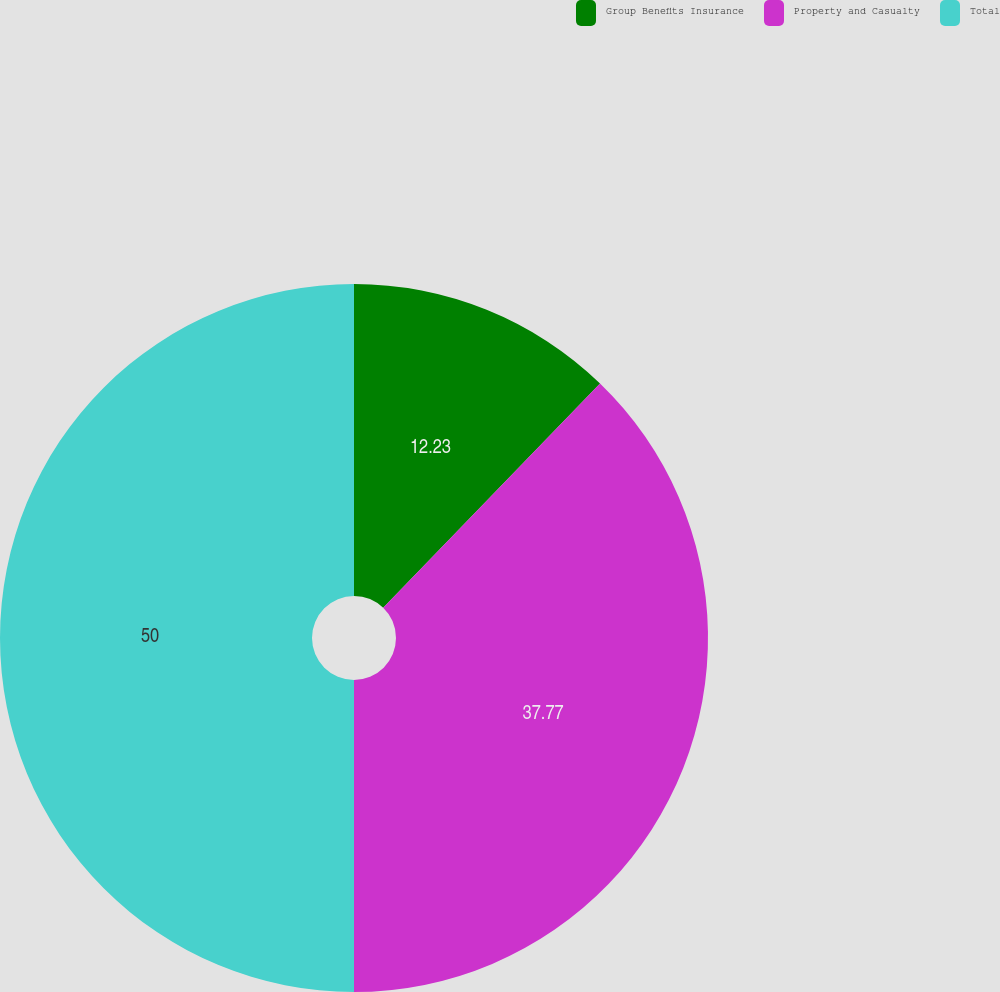<chart> <loc_0><loc_0><loc_500><loc_500><pie_chart><fcel>Group Benefits Insurance<fcel>Property and Casualty<fcel>Total<nl><fcel>12.23%<fcel>37.77%<fcel>50.0%<nl></chart> 